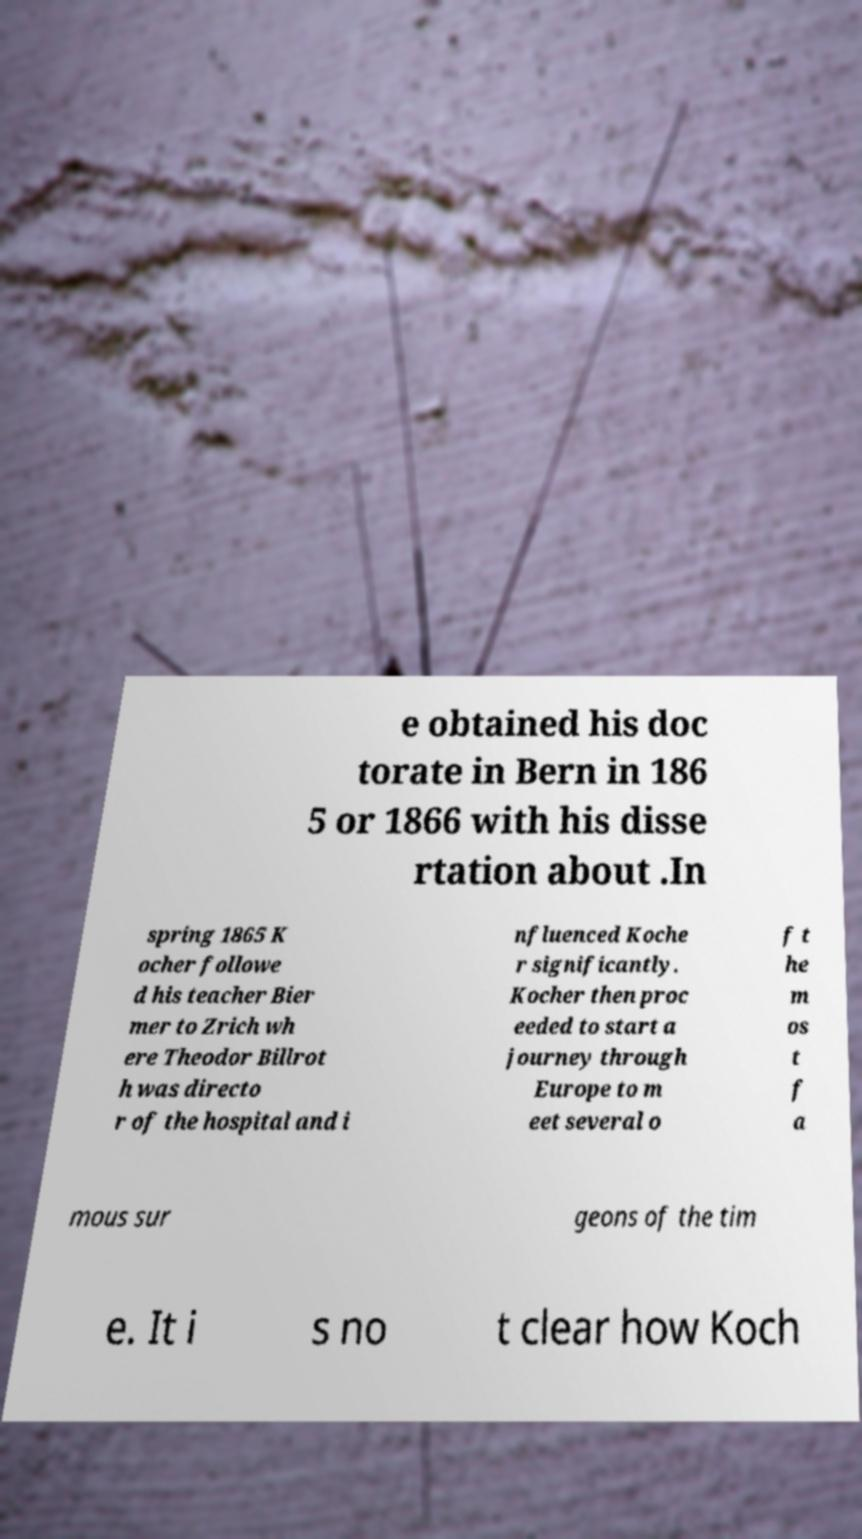Please read and relay the text visible in this image. What does it say? e obtained his doc torate in Bern in 186 5 or 1866 with his disse rtation about .In spring 1865 K ocher followe d his teacher Bier mer to Zrich wh ere Theodor Billrot h was directo r of the hospital and i nfluenced Koche r significantly. Kocher then proc eeded to start a journey through Europe to m eet several o f t he m os t f a mous sur geons of the tim e. It i s no t clear how Koch 